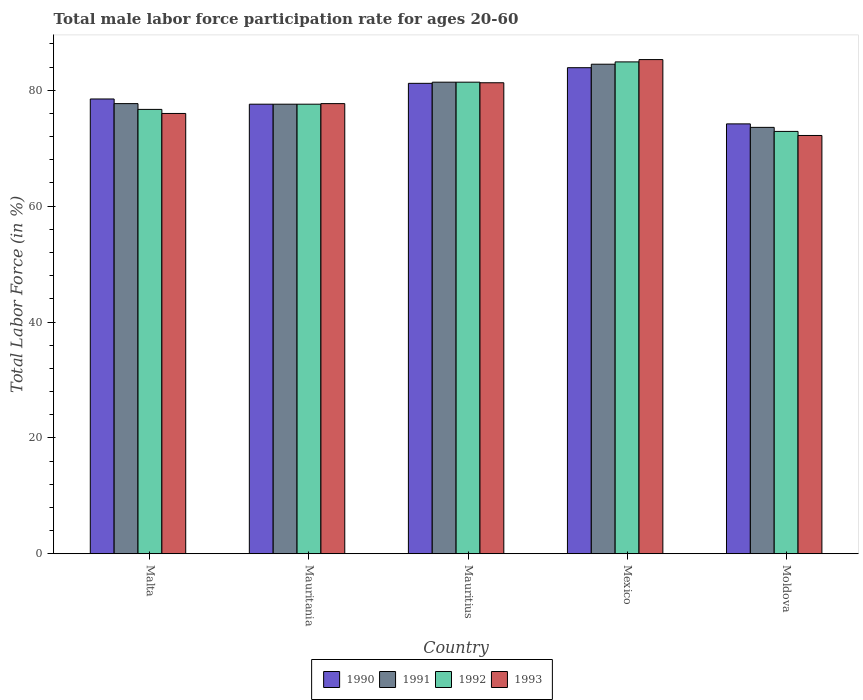How many groups of bars are there?
Ensure brevity in your answer.  5. Are the number of bars per tick equal to the number of legend labels?
Provide a succinct answer. Yes. How many bars are there on the 3rd tick from the left?
Offer a terse response. 4. What is the label of the 3rd group of bars from the left?
Make the answer very short. Mauritius. In how many cases, is the number of bars for a given country not equal to the number of legend labels?
Your answer should be compact. 0. Across all countries, what is the maximum male labor force participation rate in 1993?
Provide a short and direct response. 85.3. Across all countries, what is the minimum male labor force participation rate in 1993?
Your answer should be compact. 72.2. In which country was the male labor force participation rate in 1991 minimum?
Your answer should be very brief. Moldova. What is the total male labor force participation rate in 1990 in the graph?
Your answer should be compact. 395.4. What is the difference between the male labor force participation rate in 1990 in Malta and that in Mauritius?
Your answer should be very brief. -2.7. What is the difference between the male labor force participation rate in 1990 in Moldova and the male labor force participation rate in 1993 in Malta?
Make the answer very short. -1.8. What is the average male labor force participation rate in 1993 per country?
Your answer should be very brief. 78.5. What is the difference between the male labor force participation rate of/in 1993 and male labor force participation rate of/in 1992 in Mauritius?
Ensure brevity in your answer.  -0.1. In how many countries, is the male labor force participation rate in 1993 greater than 24 %?
Provide a succinct answer. 5. What is the ratio of the male labor force participation rate in 1991 in Malta to that in Mexico?
Make the answer very short. 0.92. What is the difference between the highest and the second highest male labor force participation rate in 1993?
Ensure brevity in your answer.  3.6. What is the difference between the highest and the lowest male labor force participation rate in 1993?
Offer a very short reply. 13.1. Is it the case that in every country, the sum of the male labor force participation rate in 1991 and male labor force participation rate in 1990 is greater than the sum of male labor force participation rate in 1993 and male labor force participation rate in 1992?
Your answer should be very brief. No. What does the 4th bar from the right in Mauritania represents?
Provide a short and direct response. 1990. Are all the bars in the graph horizontal?
Your answer should be very brief. No. Are the values on the major ticks of Y-axis written in scientific E-notation?
Your answer should be very brief. No. Does the graph contain grids?
Your response must be concise. No. Where does the legend appear in the graph?
Your response must be concise. Bottom center. How many legend labels are there?
Give a very brief answer. 4. What is the title of the graph?
Provide a succinct answer. Total male labor force participation rate for ages 20-60. What is the label or title of the X-axis?
Offer a very short reply. Country. What is the Total Labor Force (in %) in 1990 in Malta?
Ensure brevity in your answer.  78.5. What is the Total Labor Force (in %) of 1991 in Malta?
Offer a terse response. 77.7. What is the Total Labor Force (in %) in 1992 in Malta?
Keep it short and to the point. 76.7. What is the Total Labor Force (in %) of 1993 in Malta?
Make the answer very short. 76. What is the Total Labor Force (in %) in 1990 in Mauritania?
Offer a terse response. 77.6. What is the Total Labor Force (in %) in 1991 in Mauritania?
Your response must be concise. 77.6. What is the Total Labor Force (in %) in 1992 in Mauritania?
Provide a succinct answer. 77.6. What is the Total Labor Force (in %) in 1993 in Mauritania?
Provide a succinct answer. 77.7. What is the Total Labor Force (in %) in 1990 in Mauritius?
Your response must be concise. 81.2. What is the Total Labor Force (in %) in 1991 in Mauritius?
Offer a very short reply. 81.4. What is the Total Labor Force (in %) in 1992 in Mauritius?
Provide a short and direct response. 81.4. What is the Total Labor Force (in %) in 1993 in Mauritius?
Your response must be concise. 81.3. What is the Total Labor Force (in %) of 1990 in Mexico?
Your response must be concise. 83.9. What is the Total Labor Force (in %) of 1991 in Mexico?
Your answer should be compact. 84.5. What is the Total Labor Force (in %) in 1992 in Mexico?
Your answer should be compact. 84.9. What is the Total Labor Force (in %) in 1993 in Mexico?
Give a very brief answer. 85.3. What is the Total Labor Force (in %) of 1990 in Moldova?
Keep it short and to the point. 74.2. What is the Total Labor Force (in %) in 1991 in Moldova?
Offer a terse response. 73.6. What is the Total Labor Force (in %) in 1992 in Moldova?
Provide a succinct answer. 72.9. What is the Total Labor Force (in %) in 1993 in Moldova?
Your answer should be compact. 72.2. Across all countries, what is the maximum Total Labor Force (in %) in 1990?
Give a very brief answer. 83.9. Across all countries, what is the maximum Total Labor Force (in %) of 1991?
Your answer should be compact. 84.5. Across all countries, what is the maximum Total Labor Force (in %) in 1992?
Your answer should be very brief. 84.9. Across all countries, what is the maximum Total Labor Force (in %) of 1993?
Give a very brief answer. 85.3. Across all countries, what is the minimum Total Labor Force (in %) of 1990?
Provide a short and direct response. 74.2. Across all countries, what is the minimum Total Labor Force (in %) of 1991?
Provide a succinct answer. 73.6. Across all countries, what is the minimum Total Labor Force (in %) of 1992?
Give a very brief answer. 72.9. Across all countries, what is the minimum Total Labor Force (in %) of 1993?
Keep it short and to the point. 72.2. What is the total Total Labor Force (in %) of 1990 in the graph?
Keep it short and to the point. 395.4. What is the total Total Labor Force (in %) of 1991 in the graph?
Ensure brevity in your answer.  394.8. What is the total Total Labor Force (in %) in 1992 in the graph?
Provide a short and direct response. 393.5. What is the total Total Labor Force (in %) of 1993 in the graph?
Your answer should be compact. 392.5. What is the difference between the Total Labor Force (in %) of 1990 in Malta and that in Mauritania?
Keep it short and to the point. 0.9. What is the difference between the Total Labor Force (in %) in 1993 in Malta and that in Mauritania?
Keep it short and to the point. -1.7. What is the difference between the Total Labor Force (in %) in 1990 in Malta and that in Moldova?
Make the answer very short. 4.3. What is the difference between the Total Labor Force (in %) in 1991 in Malta and that in Moldova?
Make the answer very short. 4.1. What is the difference between the Total Labor Force (in %) in 1993 in Mauritania and that in Mauritius?
Ensure brevity in your answer.  -3.6. What is the difference between the Total Labor Force (in %) in 1992 in Mauritania and that in Mexico?
Your answer should be very brief. -7.3. What is the difference between the Total Labor Force (in %) of 1993 in Mauritania and that in Mexico?
Provide a short and direct response. -7.6. What is the difference between the Total Labor Force (in %) of 1990 in Mauritania and that in Moldova?
Give a very brief answer. 3.4. What is the difference between the Total Labor Force (in %) of 1990 in Mauritius and that in Mexico?
Keep it short and to the point. -2.7. What is the difference between the Total Labor Force (in %) in 1991 in Mauritius and that in Mexico?
Offer a terse response. -3.1. What is the difference between the Total Labor Force (in %) in 1993 in Mauritius and that in Mexico?
Provide a succinct answer. -4. What is the difference between the Total Labor Force (in %) in 1991 in Mauritius and that in Moldova?
Your answer should be compact. 7.8. What is the difference between the Total Labor Force (in %) of 1990 in Malta and the Total Labor Force (in %) of 1991 in Mauritania?
Your answer should be compact. 0.9. What is the difference between the Total Labor Force (in %) of 1990 in Malta and the Total Labor Force (in %) of 1992 in Mauritania?
Offer a very short reply. 0.9. What is the difference between the Total Labor Force (in %) in 1990 in Malta and the Total Labor Force (in %) in 1991 in Mauritius?
Provide a short and direct response. -2.9. What is the difference between the Total Labor Force (in %) of 1990 in Malta and the Total Labor Force (in %) of 1992 in Mauritius?
Offer a very short reply. -2.9. What is the difference between the Total Labor Force (in %) of 1990 in Malta and the Total Labor Force (in %) of 1993 in Mauritius?
Keep it short and to the point. -2.8. What is the difference between the Total Labor Force (in %) in 1991 in Malta and the Total Labor Force (in %) in 1993 in Mauritius?
Offer a terse response. -3.6. What is the difference between the Total Labor Force (in %) of 1992 in Malta and the Total Labor Force (in %) of 1993 in Mauritius?
Keep it short and to the point. -4.6. What is the difference between the Total Labor Force (in %) in 1990 in Malta and the Total Labor Force (in %) in 1991 in Mexico?
Provide a short and direct response. -6. What is the difference between the Total Labor Force (in %) of 1990 in Malta and the Total Labor Force (in %) of 1992 in Mexico?
Your answer should be compact. -6.4. What is the difference between the Total Labor Force (in %) in 1990 in Malta and the Total Labor Force (in %) in 1991 in Moldova?
Keep it short and to the point. 4.9. What is the difference between the Total Labor Force (in %) of 1990 in Malta and the Total Labor Force (in %) of 1992 in Moldova?
Offer a very short reply. 5.6. What is the difference between the Total Labor Force (in %) in 1991 in Malta and the Total Labor Force (in %) in 1992 in Moldova?
Offer a very short reply. 4.8. What is the difference between the Total Labor Force (in %) in 1990 in Mauritania and the Total Labor Force (in %) in 1991 in Mauritius?
Ensure brevity in your answer.  -3.8. What is the difference between the Total Labor Force (in %) of 1990 in Mauritania and the Total Labor Force (in %) of 1993 in Mauritius?
Provide a short and direct response. -3.7. What is the difference between the Total Labor Force (in %) of 1991 in Mauritania and the Total Labor Force (in %) of 1992 in Mauritius?
Provide a short and direct response. -3.8. What is the difference between the Total Labor Force (in %) in 1990 in Mauritania and the Total Labor Force (in %) in 1991 in Mexico?
Your answer should be very brief. -6.9. What is the difference between the Total Labor Force (in %) of 1990 in Mauritania and the Total Labor Force (in %) of 1993 in Mexico?
Your response must be concise. -7.7. What is the difference between the Total Labor Force (in %) of 1991 in Mauritania and the Total Labor Force (in %) of 1992 in Mexico?
Make the answer very short. -7.3. What is the difference between the Total Labor Force (in %) in 1992 in Mauritania and the Total Labor Force (in %) in 1993 in Mexico?
Offer a terse response. -7.7. What is the difference between the Total Labor Force (in %) in 1990 in Mauritania and the Total Labor Force (in %) in 1992 in Moldova?
Offer a terse response. 4.7. What is the difference between the Total Labor Force (in %) of 1991 in Mauritania and the Total Labor Force (in %) of 1992 in Moldova?
Offer a terse response. 4.7. What is the difference between the Total Labor Force (in %) in 1992 in Mauritania and the Total Labor Force (in %) in 1993 in Moldova?
Your answer should be very brief. 5.4. What is the difference between the Total Labor Force (in %) of 1990 in Mauritius and the Total Labor Force (in %) of 1991 in Mexico?
Offer a terse response. -3.3. What is the difference between the Total Labor Force (in %) in 1991 in Mauritius and the Total Labor Force (in %) in 1993 in Mexico?
Your answer should be compact. -3.9. What is the difference between the Total Labor Force (in %) of 1990 in Mauritius and the Total Labor Force (in %) of 1992 in Moldova?
Offer a very short reply. 8.3. What is the difference between the Total Labor Force (in %) in 1990 in Mauritius and the Total Labor Force (in %) in 1993 in Moldova?
Give a very brief answer. 9. What is the difference between the Total Labor Force (in %) in 1991 in Mauritius and the Total Labor Force (in %) in 1993 in Moldova?
Your response must be concise. 9.2. What is the difference between the Total Labor Force (in %) of 1990 in Mexico and the Total Labor Force (in %) of 1991 in Moldova?
Offer a very short reply. 10.3. What is the difference between the Total Labor Force (in %) of 1990 in Mexico and the Total Labor Force (in %) of 1992 in Moldova?
Offer a very short reply. 11. What is the difference between the Total Labor Force (in %) of 1990 in Mexico and the Total Labor Force (in %) of 1993 in Moldova?
Ensure brevity in your answer.  11.7. What is the difference between the Total Labor Force (in %) in 1991 in Mexico and the Total Labor Force (in %) in 1992 in Moldova?
Your answer should be very brief. 11.6. What is the difference between the Total Labor Force (in %) of 1991 in Mexico and the Total Labor Force (in %) of 1993 in Moldova?
Your answer should be very brief. 12.3. What is the average Total Labor Force (in %) in 1990 per country?
Your answer should be compact. 79.08. What is the average Total Labor Force (in %) of 1991 per country?
Give a very brief answer. 78.96. What is the average Total Labor Force (in %) in 1992 per country?
Offer a terse response. 78.7. What is the average Total Labor Force (in %) in 1993 per country?
Your response must be concise. 78.5. What is the difference between the Total Labor Force (in %) in 1990 and Total Labor Force (in %) in 1991 in Malta?
Make the answer very short. 0.8. What is the difference between the Total Labor Force (in %) of 1990 and Total Labor Force (in %) of 1992 in Malta?
Keep it short and to the point. 1.8. What is the difference between the Total Labor Force (in %) of 1990 and Total Labor Force (in %) of 1993 in Malta?
Keep it short and to the point. 2.5. What is the difference between the Total Labor Force (in %) in 1991 and Total Labor Force (in %) in 1992 in Malta?
Your response must be concise. 1. What is the difference between the Total Labor Force (in %) of 1991 and Total Labor Force (in %) of 1993 in Malta?
Your response must be concise. 1.7. What is the difference between the Total Labor Force (in %) in 1992 and Total Labor Force (in %) in 1993 in Malta?
Keep it short and to the point. 0.7. What is the difference between the Total Labor Force (in %) in 1990 and Total Labor Force (in %) in 1992 in Mauritania?
Provide a short and direct response. 0. What is the difference between the Total Labor Force (in %) in 1990 and Total Labor Force (in %) in 1993 in Mauritania?
Ensure brevity in your answer.  -0.1. What is the difference between the Total Labor Force (in %) in 1992 and Total Labor Force (in %) in 1993 in Mauritania?
Keep it short and to the point. -0.1. What is the difference between the Total Labor Force (in %) of 1990 and Total Labor Force (in %) of 1991 in Mauritius?
Your response must be concise. -0.2. What is the difference between the Total Labor Force (in %) of 1990 and Total Labor Force (in %) of 1992 in Mauritius?
Provide a short and direct response. -0.2. What is the difference between the Total Labor Force (in %) of 1990 and Total Labor Force (in %) of 1993 in Mauritius?
Make the answer very short. -0.1. What is the difference between the Total Labor Force (in %) of 1991 and Total Labor Force (in %) of 1992 in Mauritius?
Make the answer very short. 0. What is the difference between the Total Labor Force (in %) in 1991 and Total Labor Force (in %) in 1993 in Mauritius?
Offer a very short reply. 0.1. What is the difference between the Total Labor Force (in %) in 1992 and Total Labor Force (in %) in 1993 in Mauritius?
Provide a succinct answer. 0.1. What is the difference between the Total Labor Force (in %) of 1990 and Total Labor Force (in %) of 1991 in Mexico?
Give a very brief answer. -0.6. What is the difference between the Total Labor Force (in %) in 1990 and Total Labor Force (in %) in 1992 in Mexico?
Make the answer very short. -1. What is the difference between the Total Labor Force (in %) in 1990 and Total Labor Force (in %) in 1993 in Mexico?
Keep it short and to the point. -1.4. What is the difference between the Total Labor Force (in %) in 1991 and Total Labor Force (in %) in 1992 in Mexico?
Your response must be concise. -0.4. What is the difference between the Total Labor Force (in %) in 1992 and Total Labor Force (in %) in 1993 in Mexico?
Your answer should be very brief. -0.4. What is the difference between the Total Labor Force (in %) in 1990 and Total Labor Force (in %) in 1992 in Moldova?
Provide a succinct answer. 1.3. What is the difference between the Total Labor Force (in %) of 1991 and Total Labor Force (in %) of 1992 in Moldova?
Your answer should be very brief. 0.7. What is the ratio of the Total Labor Force (in %) of 1990 in Malta to that in Mauritania?
Offer a very short reply. 1.01. What is the ratio of the Total Labor Force (in %) of 1991 in Malta to that in Mauritania?
Give a very brief answer. 1. What is the ratio of the Total Labor Force (in %) in 1992 in Malta to that in Mauritania?
Give a very brief answer. 0.99. What is the ratio of the Total Labor Force (in %) in 1993 in Malta to that in Mauritania?
Your response must be concise. 0.98. What is the ratio of the Total Labor Force (in %) of 1990 in Malta to that in Mauritius?
Keep it short and to the point. 0.97. What is the ratio of the Total Labor Force (in %) in 1991 in Malta to that in Mauritius?
Provide a succinct answer. 0.95. What is the ratio of the Total Labor Force (in %) of 1992 in Malta to that in Mauritius?
Provide a short and direct response. 0.94. What is the ratio of the Total Labor Force (in %) in 1993 in Malta to that in Mauritius?
Make the answer very short. 0.93. What is the ratio of the Total Labor Force (in %) of 1990 in Malta to that in Mexico?
Offer a terse response. 0.94. What is the ratio of the Total Labor Force (in %) in 1991 in Malta to that in Mexico?
Your answer should be very brief. 0.92. What is the ratio of the Total Labor Force (in %) in 1992 in Malta to that in Mexico?
Your answer should be very brief. 0.9. What is the ratio of the Total Labor Force (in %) in 1993 in Malta to that in Mexico?
Your answer should be compact. 0.89. What is the ratio of the Total Labor Force (in %) of 1990 in Malta to that in Moldova?
Provide a short and direct response. 1.06. What is the ratio of the Total Labor Force (in %) of 1991 in Malta to that in Moldova?
Make the answer very short. 1.06. What is the ratio of the Total Labor Force (in %) in 1992 in Malta to that in Moldova?
Ensure brevity in your answer.  1.05. What is the ratio of the Total Labor Force (in %) of 1993 in Malta to that in Moldova?
Offer a very short reply. 1.05. What is the ratio of the Total Labor Force (in %) of 1990 in Mauritania to that in Mauritius?
Provide a succinct answer. 0.96. What is the ratio of the Total Labor Force (in %) of 1991 in Mauritania to that in Mauritius?
Provide a succinct answer. 0.95. What is the ratio of the Total Labor Force (in %) in 1992 in Mauritania to that in Mauritius?
Keep it short and to the point. 0.95. What is the ratio of the Total Labor Force (in %) in 1993 in Mauritania to that in Mauritius?
Provide a short and direct response. 0.96. What is the ratio of the Total Labor Force (in %) in 1990 in Mauritania to that in Mexico?
Make the answer very short. 0.92. What is the ratio of the Total Labor Force (in %) of 1991 in Mauritania to that in Mexico?
Make the answer very short. 0.92. What is the ratio of the Total Labor Force (in %) in 1992 in Mauritania to that in Mexico?
Give a very brief answer. 0.91. What is the ratio of the Total Labor Force (in %) in 1993 in Mauritania to that in Mexico?
Offer a terse response. 0.91. What is the ratio of the Total Labor Force (in %) in 1990 in Mauritania to that in Moldova?
Make the answer very short. 1.05. What is the ratio of the Total Labor Force (in %) in 1991 in Mauritania to that in Moldova?
Your answer should be very brief. 1.05. What is the ratio of the Total Labor Force (in %) of 1992 in Mauritania to that in Moldova?
Your answer should be very brief. 1.06. What is the ratio of the Total Labor Force (in %) in 1993 in Mauritania to that in Moldova?
Your answer should be very brief. 1.08. What is the ratio of the Total Labor Force (in %) in 1990 in Mauritius to that in Mexico?
Your answer should be very brief. 0.97. What is the ratio of the Total Labor Force (in %) of 1991 in Mauritius to that in Mexico?
Ensure brevity in your answer.  0.96. What is the ratio of the Total Labor Force (in %) in 1992 in Mauritius to that in Mexico?
Your answer should be very brief. 0.96. What is the ratio of the Total Labor Force (in %) in 1993 in Mauritius to that in Mexico?
Ensure brevity in your answer.  0.95. What is the ratio of the Total Labor Force (in %) of 1990 in Mauritius to that in Moldova?
Keep it short and to the point. 1.09. What is the ratio of the Total Labor Force (in %) in 1991 in Mauritius to that in Moldova?
Your response must be concise. 1.11. What is the ratio of the Total Labor Force (in %) in 1992 in Mauritius to that in Moldova?
Ensure brevity in your answer.  1.12. What is the ratio of the Total Labor Force (in %) in 1993 in Mauritius to that in Moldova?
Provide a succinct answer. 1.13. What is the ratio of the Total Labor Force (in %) in 1990 in Mexico to that in Moldova?
Ensure brevity in your answer.  1.13. What is the ratio of the Total Labor Force (in %) in 1991 in Mexico to that in Moldova?
Offer a terse response. 1.15. What is the ratio of the Total Labor Force (in %) of 1992 in Mexico to that in Moldova?
Your answer should be very brief. 1.16. What is the ratio of the Total Labor Force (in %) of 1993 in Mexico to that in Moldova?
Your response must be concise. 1.18. What is the difference between the highest and the second highest Total Labor Force (in %) in 1990?
Ensure brevity in your answer.  2.7. What is the difference between the highest and the lowest Total Labor Force (in %) of 1991?
Make the answer very short. 10.9. 